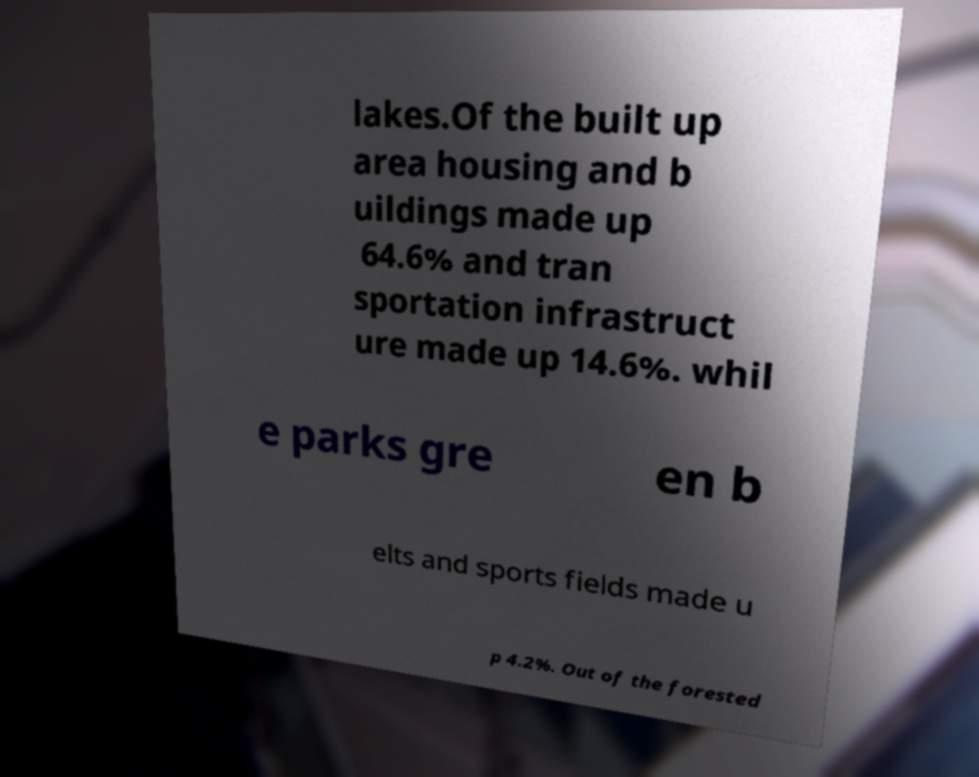Can you read and provide the text displayed in the image?This photo seems to have some interesting text. Can you extract and type it out for me? lakes.Of the built up area housing and b uildings made up 64.6% and tran sportation infrastruct ure made up 14.6%. whil e parks gre en b elts and sports fields made u p 4.2%. Out of the forested 